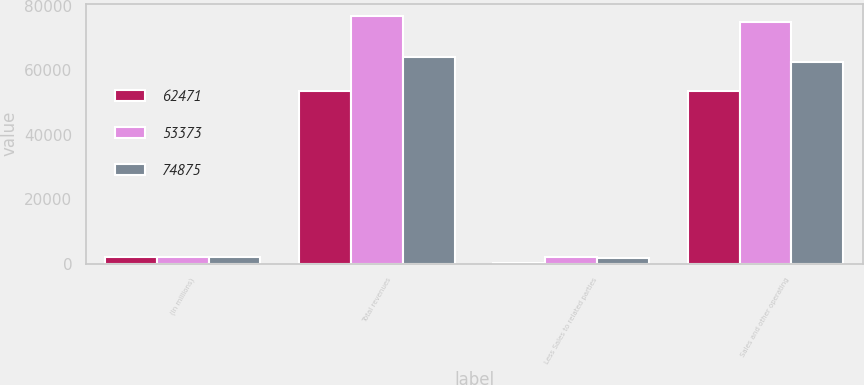Convert chart to OTSL. <chart><loc_0><loc_0><loc_500><loc_500><stacked_bar_chart><ecel><fcel>(In millions)<fcel>Total revenues<fcel>Less Sales to related parties<fcel>Sales and other operating<nl><fcel>62471<fcel>2009<fcel>53470<fcel>97<fcel>53373<nl><fcel>53373<fcel>2008<fcel>76754<fcel>1879<fcel>74875<nl><fcel>74875<fcel>2007<fcel>64096<fcel>1625<fcel>62471<nl></chart> 